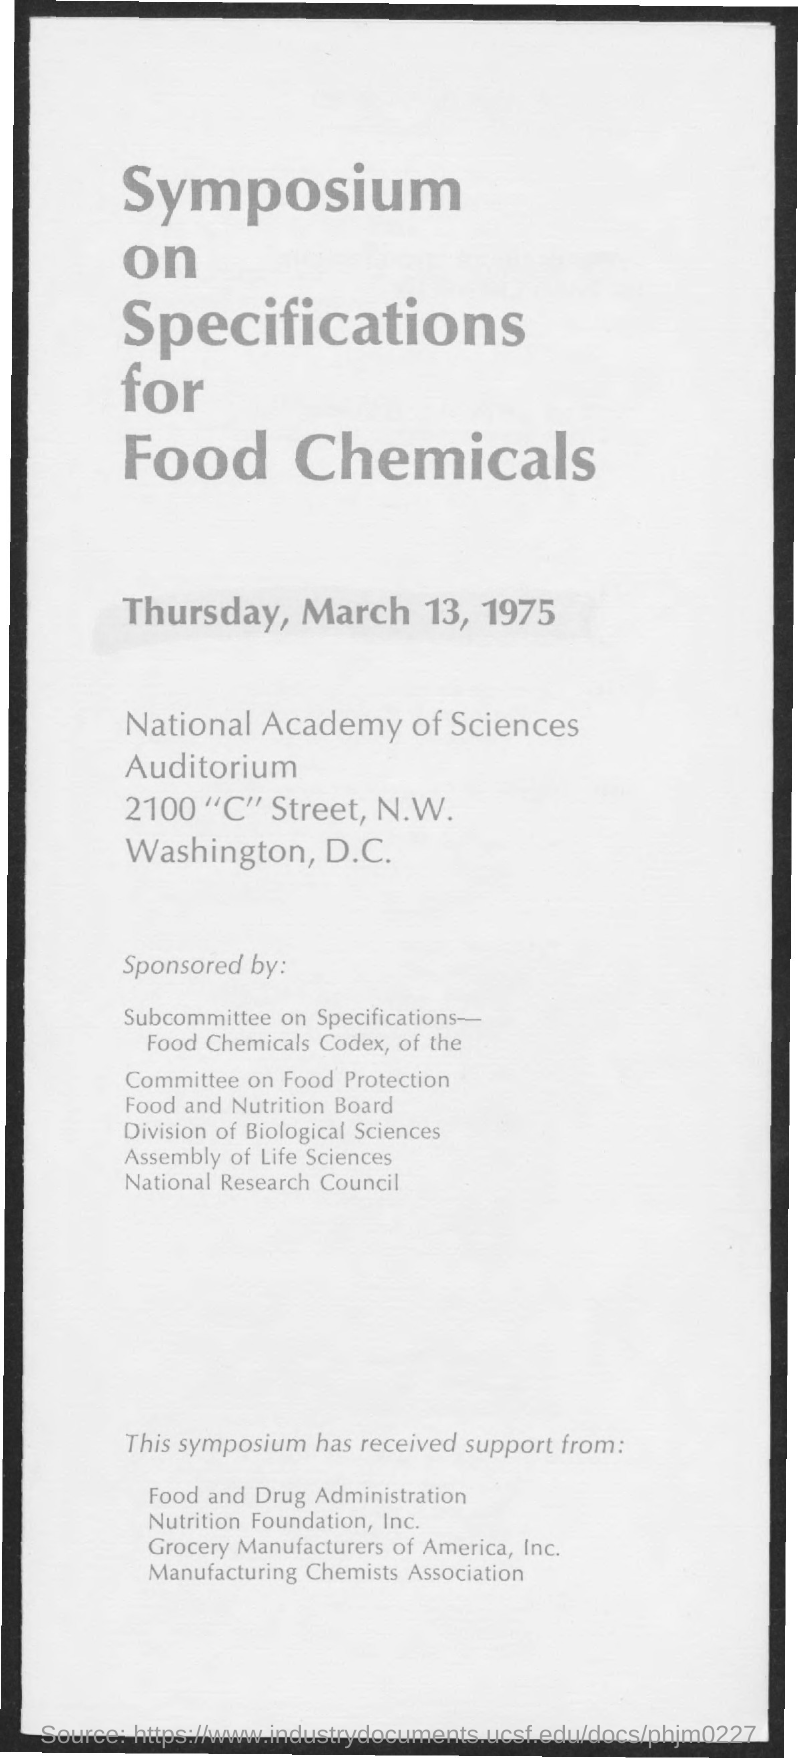What is the date mentioned in the given page ?
Your response must be concise. Thursday, march 13, 1975. 